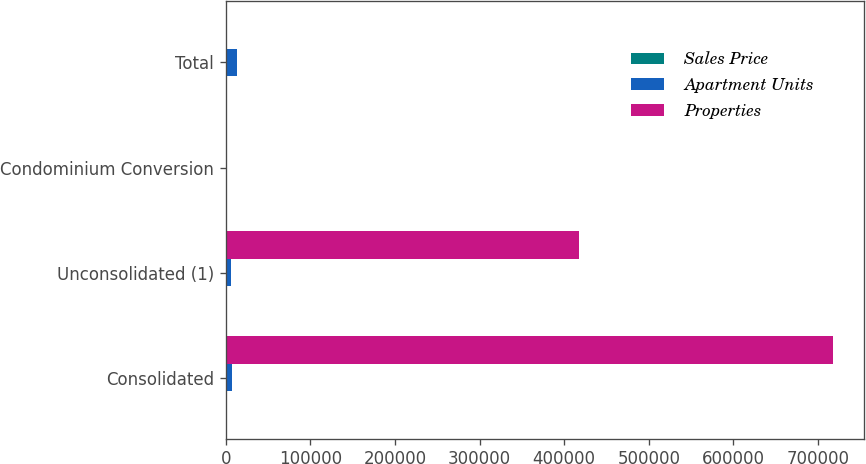Convert chart to OTSL. <chart><loc_0><loc_0><loc_500><loc_500><stacked_bar_chart><ecel><fcel>Consolidated<fcel>Unconsolidated (1)<fcel>Condominium Conversion<fcel>Total<nl><fcel>Sales Price<fcel>35<fcel>27<fcel>1<fcel>63<nl><fcel>Apartment Units<fcel>7171<fcel>6275<fcel>2<fcel>13448<nl><fcel>Properties<fcel>718352<fcel>417779<fcel>360<fcel>360<nl></chart> 